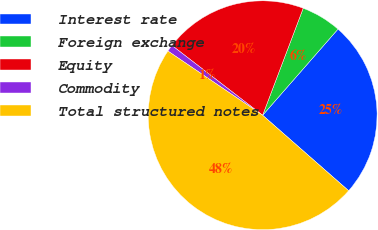Convert chart. <chart><loc_0><loc_0><loc_500><loc_500><pie_chart><fcel>Interest rate<fcel>Foreign exchange<fcel>Equity<fcel>Commodity<fcel>Total structured notes<nl><fcel>25.03%<fcel>5.67%<fcel>20.33%<fcel>0.96%<fcel>48.02%<nl></chart> 